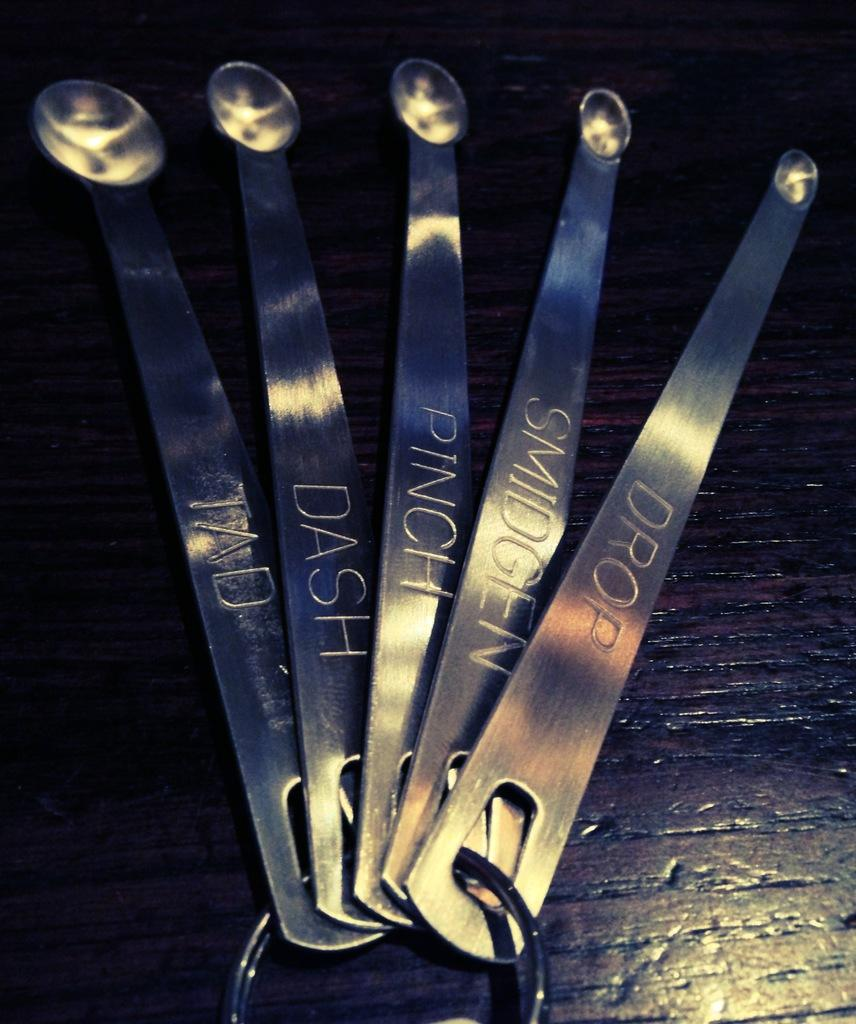What is the color of the objects in the image? The objects in the image are silver-colored. What is written on the silver-colored objects? There are words written on the silver-colored objects. What is the surface on which the objects are placed? The objects are on a brown surface. What type of jelly is being served for breakfast on the brown surface in the image? There is no jelly or breakfast scene present in the image; it features five silver-colored objects with words written on them. 